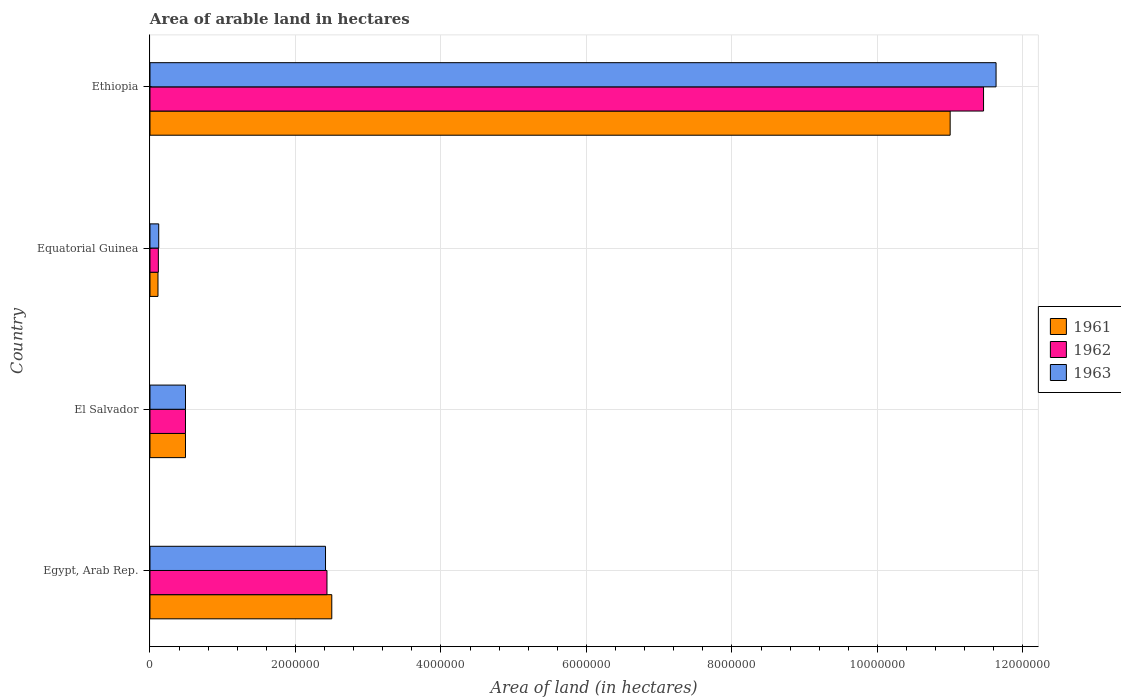Are the number of bars per tick equal to the number of legend labels?
Your answer should be compact. Yes. How many bars are there on the 1st tick from the bottom?
Your response must be concise. 3. What is the label of the 3rd group of bars from the top?
Provide a succinct answer. El Salvador. In how many cases, is the number of bars for a given country not equal to the number of legend labels?
Provide a short and direct response. 0. What is the total arable land in 1961 in Egypt, Arab Rep.?
Make the answer very short. 2.50e+06. Across all countries, what is the maximum total arable land in 1962?
Your answer should be compact. 1.15e+07. Across all countries, what is the minimum total arable land in 1962?
Provide a succinct answer. 1.15e+05. In which country was the total arable land in 1962 maximum?
Make the answer very short. Ethiopia. In which country was the total arable land in 1963 minimum?
Your answer should be very brief. Equatorial Guinea. What is the total total arable land in 1961 in the graph?
Make the answer very short. 1.41e+07. What is the difference between the total arable land in 1963 in Egypt, Arab Rep. and that in Ethiopia?
Provide a short and direct response. -9.22e+06. What is the difference between the total arable land in 1963 in El Salvador and the total arable land in 1962 in Ethiopia?
Offer a terse response. -1.10e+07. What is the average total arable land in 1961 per country?
Keep it short and to the point. 3.52e+06. What is the difference between the total arable land in 1961 and total arable land in 1962 in Ethiopia?
Your response must be concise. -4.59e+05. In how many countries, is the total arable land in 1961 greater than 400000 hectares?
Provide a short and direct response. 3. What is the ratio of the total arable land in 1963 in El Salvador to that in Equatorial Guinea?
Give a very brief answer. 4.07. Is the total arable land in 1962 in El Salvador less than that in Equatorial Guinea?
Give a very brief answer. No. What is the difference between the highest and the second highest total arable land in 1962?
Your answer should be compact. 9.03e+06. What is the difference between the highest and the lowest total arable land in 1962?
Offer a terse response. 1.13e+07. Is the sum of the total arable land in 1962 in El Salvador and Equatorial Guinea greater than the maximum total arable land in 1963 across all countries?
Offer a terse response. No. How many bars are there?
Provide a short and direct response. 12. Are all the bars in the graph horizontal?
Provide a succinct answer. Yes. How many countries are there in the graph?
Ensure brevity in your answer.  4. Does the graph contain any zero values?
Give a very brief answer. No. How are the legend labels stacked?
Keep it short and to the point. Vertical. What is the title of the graph?
Provide a short and direct response. Area of arable land in hectares. What is the label or title of the X-axis?
Provide a succinct answer. Area of land (in hectares). What is the label or title of the Y-axis?
Ensure brevity in your answer.  Country. What is the Area of land (in hectares) in 1961 in Egypt, Arab Rep.?
Your answer should be very brief. 2.50e+06. What is the Area of land (in hectares) of 1962 in Egypt, Arab Rep.?
Make the answer very short. 2.43e+06. What is the Area of land (in hectares) of 1963 in Egypt, Arab Rep.?
Keep it short and to the point. 2.41e+06. What is the Area of land (in hectares) of 1961 in El Salvador?
Give a very brief answer. 4.88e+05. What is the Area of land (in hectares) in 1962 in El Salvador?
Provide a succinct answer. 4.88e+05. What is the Area of land (in hectares) of 1963 in El Salvador?
Keep it short and to the point. 4.88e+05. What is the Area of land (in hectares) of 1962 in Equatorial Guinea?
Give a very brief answer. 1.15e+05. What is the Area of land (in hectares) of 1961 in Ethiopia?
Ensure brevity in your answer.  1.10e+07. What is the Area of land (in hectares) of 1962 in Ethiopia?
Provide a succinct answer. 1.15e+07. What is the Area of land (in hectares) of 1963 in Ethiopia?
Your answer should be very brief. 1.16e+07. Across all countries, what is the maximum Area of land (in hectares) in 1961?
Your response must be concise. 1.10e+07. Across all countries, what is the maximum Area of land (in hectares) in 1962?
Offer a very short reply. 1.15e+07. Across all countries, what is the maximum Area of land (in hectares) in 1963?
Offer a terse response. 1.16e+07. Across all countries, what is the minimum Area of land (in hectares) in 1961?
Provide a succinct answer. 1.10e+05. Across all countries, what is the minimum Area of land (in hectares) of 1962?
Your answer should be very brief. 1.15e+05. What is the total Area of land (in hectares) of 1961 in the graph?
Keep it short and to the point. 1.41e+07. What is the total Area of land (in hectares) in 1962 in the graph?
Your answer should be very brief. 1.45e+07. What is the total Area of land (in hectares) in 1963 in the graph?
Provide a succinct answer. 1.47e+07. What is the difference between the Area of land (in hectares) in 1961 in Egypt, Arab Rep. and that in El Salvador?
Give a very brief answer. 2.01e+06. What is the difference between the Area of land (in hectares) in 1962 in Egypt, Arab Rep. and that in El Salvador?
Keep it short and to the point. 1.94e+06. What is the difference between the Area of land (in hectares) in 1963 in Egypt, Arab Rep. and that in El Salvador?
Provide a short and direct response. 1.92e+06. What is the difference between the Area of land (in hectares) of 1961 in Egypt, Arab Rep. and that in Equatorial Guinea?
Provide a short and direct response. 2.39e+06. What is the difference between the Area of land (in hectares) of 1962 in Egypt, Arab Rep. and that in Equatorial Guinea?
Make the answer very short. 2.32e+06. What is the difference between the Area of land (in hectares) of 1963 in Egypt, Arab Rep. and that in Equatorial Guinea?
Make the answer very short. 2.29e+06. What is the difference between the Area of land (in hectares) of 1961 in Egypt, Arab Rep. and that in Ethiopia?
Your answer should be very brief. -8.50e+06. What is the difference between the Area of land (in hectares) of 1962 in Egypt, Arab Rep. and that in Ethiopia?
Provide a succinct answer. -9.03e+06. What is the difference between the Area of land (in hectares) in 1963 in Egypt, Arab Rep. and that in Ethiopia?
Ensure brevity in your answer.  -9.22e+06. What is the difference between the Area of land (in hectares) in 1961 in El Salvador and that in Equatorial Guinea?
Your answer should be compact. 3.78e+05. What is the difference between the Area of land (in hectares) of 1962 in El Salvador and that in Equatorial Guinea?
Your answer should be compact. 3.73e+05. What is the difference between the Area of land (in hectares) in 1963 in El Salvador and that in Equatorial Guinea?
Keep it short and to the point. 3.68e+05. What is the difference between the Area of land (in hectares) of 1961 in El Salvador and that in Ethiopia?
Your answer should be very brief. -1.05e+07. What is the difference between the Area of land (in hectares) of 1962 in El Salvador and that in Ethiopia?
Offer a very short reply. -1.10e+07. What is the difference between the Area of land (in hectares) of 1963 in El Salvador and that in Ethiopia?
Give a very brief answer. -1.11e+07. What is the difference between the Area of land (in hectares) in 1961 in Equatorial Guinea and that in Ethiopia?
Give a very brief answer. -1.09e+07. What is the difference between the Area of land (in hectares) of 1962 in Equatorial Guinea and that in Ethiopia?
Provide a short and direct response. -1.13e+07. What is the difference between the Area of land (in hectares) of 1963 in Equatorial Guinea and that in Ethiopia?
Offer a very short reply. -1.15e+07. What is the difference between the Area of land (in hectares) of 1961 in Egypt, Arab Rep. and the Area of land (in hectares) of 1962 in El Salvador?
Your answer should be compact. 2.01e+06. What is the difference between the Area of land (in hectares) in 1961 in Egypt, Arab Rep. and the Area of land (in hectares) in 1963 in El Salvador?
Ensure brevity in your answer.  2.01e+06. What is the difference between the Area of land (in hectares) in 1962 in Egypt, Arab Rep. and the Area of land (in hectares) in 1963 in El Salvador?
Ensure brevity in your answer.  1.94e+06. What is the difference between the Area of land (in hectares) of 1961 in Egypt, Arab Rep. and the Area of land (in hectares) of 1962 in Equatorial Guinea?
Provide a short and direct response. 2.38e+06. What is the difference between the Area of land (in hectares) in 1961 in Egypt, Arab Rep. and the Area of land (in hectares) in 1963 in Equatorial Guinea?
Give a very brief answer. 2.38e+06. What is the difference between the Area of land (in hectares) of 1962 in Egypt, Arab Rep. and the Area of land (in hectares) of 1963 in Equatorial Guinea?
Give a very brief answer. 2.31e+06. What is the difference between the Area of land (in hectares) in 1961 in Egypt, Arab Rep. and the Area of land (in hectares) in 1962 in Ethiopia?
Your answer should be compact. -8.96e+06. What is the difference between the Area of land (in hectares) of 1961 in Egypt, Arab Rep. and the Area of land (in hectares) of 1963 in Ethiopia?
Provide a short and direct response. -9.13e+06. What is the difference between the Area of land (in hectares) in 1962 in Egypt, Arab Rep. and the Area of land (in hectares) in 1963 in Ethiopia?
Provide a succinct answer. -9.20e+06. What is the difference between the Area of land (in hectares) in 1961 in El Salvador and the Area of land (in hectares) in 1962 in Equatorial Guinea?
Give a very brief answer. 3.73e+05. What is the difference between the Area of land (in hectares) in 1961 in El Salvador and the Area of land (in hectares) in 1963 in Equatorial Guinea?
Your answer should be very brief. 3.68e+05. What is the difference between the Area of land (in hectares) of 1962 in El Salvador and the Area of land (in hectares) of 1963 in Equatorial Guinea?
Ensure brevity in your answer.  3.68e+05. What is the difference between the Area of land (in hectares) in 1961 in El Salvador and the Area of land (in hectares) in 1962 in Ethiopia?
Give a very brief answer. -1.10e+07. What is the difference between the Area of land (in hectares) of 1961 in El Salvador and the Area of land (in hectares) of 1963 in Ethiopia?
Provide a succinct answer. -1.11e+07. What is the difference between the Area of land (in hectares) in 1962 in El Salvador and the Area of land (in hectares) in 1963 in Ethiopia?
Ensure brevity in your answer.  -1.11e+07. What is the difference between the Area of land (in hectares) in 1961 in Equatorial Guinea and the Area of land (in hectares) in 1962 in Ethiopia?
Your response must be concise. -1.13e+07. What is the difference between the Area of land (in hectares) in 1961 in Equatorial Guinea and the Area of land (in hectares) in 1963 in Ethiopia?
Offer a very short reply. -1.15e+07. What is the difference between the Area of land (in hectares) in 1962 in Equatorial Guinea and the Area of land (in hectares) in 1963 in Ethiopia?
Give a very brief answer. -1.15e+07. What is the average Area of land (in hectares) in 1961 per country?
Your answer should be compact. 3.52e+06. What is the average Area of land (in hectares) in 1962 per country?
Offer a very short reply. 3.62e+06. What is the average Area of land (in hectares) in 1963 per country?
Provide a succinct answer. 3.66e+06. What is the difference between the Area of land (in hectares) of 1961 and Area of land (in hectares) of 1962 in Egypt, Arab Rep.?
Your answer should be compact. 6.60e+04. What is the difference between the Area of land (in hectares) of 1961 and Area of land (in hectares) of 1963 in Egypt, Arab Rep.?
Provide a short and direct response. 8.60e+04. What is the difference between the Area of land (in hectares) in 1962 and Area of land (in hectares) in 1963 in Egypt, Arab Rep.?
Ensure brevity in your answer.  2.00e+04. What is the difference between the Area of land (in hectares) of 1961 and Area of land (in hectares) of 1962 in El Salvador?
Your answer should be very brief. 0. What is the difference between the Area of land (in hectares) in 1961 and Area of land (in hectares) in 1963 in El Salvador?
Provide a succinct answer. 0. What is the difference between the Area of land (in hectares) in 1962 and Area of land (in hectares) in 1963 in El Salvador?
Your answer should be compact. 0. What is the difference between the Area of land (in hectares) of 1961 and Area of land (in hectares) of 1962 in Equatorial Guinea?
Offer a very short reply. -5000. What is the difference between the Area of land (in hectares) of 1962 and Area of land (in hectares) of 1963 in Equatorial Guinea?
Provide a succinct answer. -5000. What is the difference between the Area of land (in hectares) in 1961 and Area of land (in hectares) in 1962 in Ethiopia?
Offer a terse response. -4.59e+05. What is the difference between the Area of land (in hectares) of 1961 and Area of land (in hectares) of 1963 in Ethiopia?
Offer a very short reply. -6.31e+05. What is the difference between the Area of land (in hectares) of 1962 and Area of land (in hectares) of 1963 in Ethiopia?
Your response must be concise. -1.72e+05. What is the ratio of the Area of land (in hectares) in 1961 in Egypt, Arab Rep. to that in El Salvador?
Your answer should be very brief. 5.12. What is the ratio of the Area of land (in hectares) of 1962 in Egypt, Arab Rep. to that in El Salvador?
Give a very brief answer. 4.99. What is the ratio of the Area of land (in hectares) of 1963 in Egypt, Arab Rep. to that in El Salvador?
Provide a succinct answer. 4.94. What is the ratio of the Area of land (in hectares) of 1961 in Egypt, Arab Rep. to that in Equatorial Guinea?
Give a very brief answer. 22.72. What is the ratio of the Area of land (in hectares) in 1962 in Egypt, Arab Rep. to that in Equatorial Guinea?
Your response must be concise. 21.16. What is the ratio of the Area of land (in hectares) in 1963 in Egypt, Arab Rep. to that in Equatorial Guinea?
Provide a short and direct response. 20.11. What is the ratio of the Area of land (in hectares) of 1961 in Egypt, Arab Rep. to that in Ethiopia?
Your response must be concise. 0.23. What is the ratio of the Area of land (in hectares) of 1962 in Egypt, Arab Rep. to that in Ethiopia?
Provide a succinct answer. 0.21. What is the ratio of the Area of land (in hectares) in 1963 in Egypt, Arab Rep. to that in Ethiopia?
Your response must be concise. 0.21. What is the ratio of the Area of land (in hectares) of 1961 in El Salvador to that in Equatorial Guinea?
Give a very brief answer. 4.44. What is the ratio of the Area of land (in hectares) of 1962 in El Salvador to that in Equatorial Guinea?
Make the answer very short. 4.24. What is the ratio of the Area of land (in hectares) in 1963 in El Salvador to that in Equatorial Guinea?
Your answer should be very brief. 4.07. What is the ratio of the Area of land (in hectares) in 1961 in El Salvador to that in Ethiopia?
Your response must be concise. 0.04. What is the ratio of the Area of land (in hectares) in 1962 in El Salvador to that in Ethiopia?
Provide a short and direct response. 0.04. What is the ratio of the Area of land (in hectares) of 1963 in El Salvador to that in Ethiopia?
Provide a short and direct response. 0.04. What is the ratio of the Area of land (in hectares) of 1962 in Equatorial Guinea to that in Ethiopia?
Ensure brevity in your answer.  0.01. What is the ratio of the Area of land (in hectares) of 1963 in Equatorial Guinea to that in Ethiopia?
Your answer should be compact. 0.01. What is the difference between the highest and the second highest Area of land (in hectares) of 1961?
Give a very brief answer. 8.50e+06. What is the difference between the highest and the second highest Area of land (in hectares) of 1962?
Offer a terse response. 9.03e+06. What is the difference between the highest and the second highest Area of land (in hectares) in 1963?
Offer a terse response. 9.22e+06. What is the difference between the highest and the lowest Area of land (in hectares) of 1961?
Offer a very short reply. 1.09e+07. What is the difference between the highest and the lowest Area of land (in hectares) in 1962?
Ensure brevity in your answer.  1.13e+07. What is the difference between the highest and the lowest Area of land (in hectares) in 1963?
Make the answer very short. 1.15e+07. 